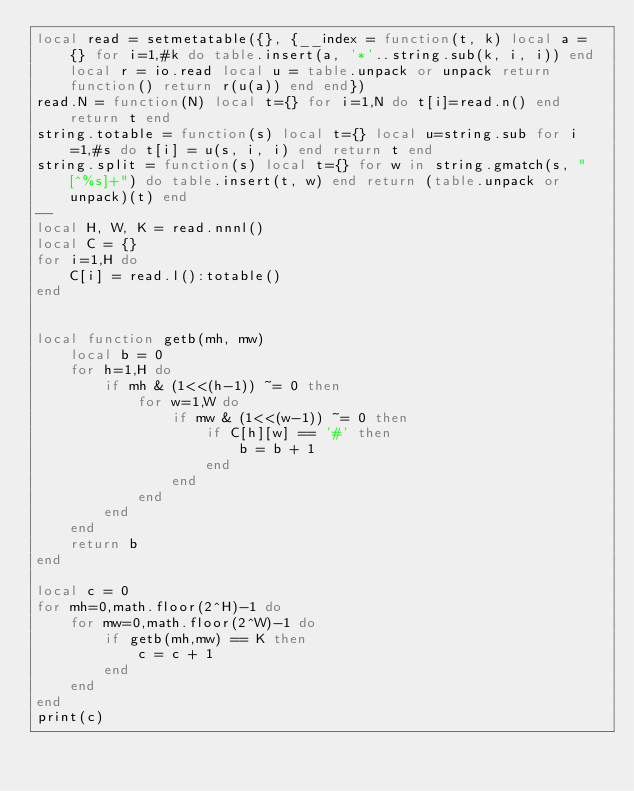Convert code to text. <code><loc_0><loc_0><loc_500><loc_500><_Lua_>local read = setmetatable({}, {__index = function(t, k) local a = {} for i=1,#k do table.insert(a, '*'..string.sub(k, i, i)) end local r = io.read local u = table.unpack or unpack return function() return r(u(a)) end end})
read.N = function(N) local t={} for i=1,N do t[i]=read.n() end return t end
string.totable = function(s) local t={} local u=string.sub for i=1,#s do t[i] = u(s, i, i) end return t end
string.split = function(s) local t={} for w in string.gmatch(s, "[^%s]+") do table.insert(t, w) end return (table.unpack or unpack)(t) end
--
local H, W, K = read.nnnl()
local C = {}
for i=1,H do
    C[i] = read.l():totable()
end


local function getb(mh, mw)
    local b = 0
    for h=1,H do
        if mh & (1<<(h-1)) ~= 0 then
            for w=1,W do
                if mw & (1<<(w-1)) ~= 0 then
                    if C[h][w] == '#' then
                        b = b + 1
                    end
                end
            end
        end
    end
    return b
end

local c = 0
for mh=0,math.floor(2^H)-1 do
    for mw=0,math.floor(2^W)-1 do
        if getb(mh,mw) == K then
            c = c + 1
        end
    end
end
print(c)</code> 